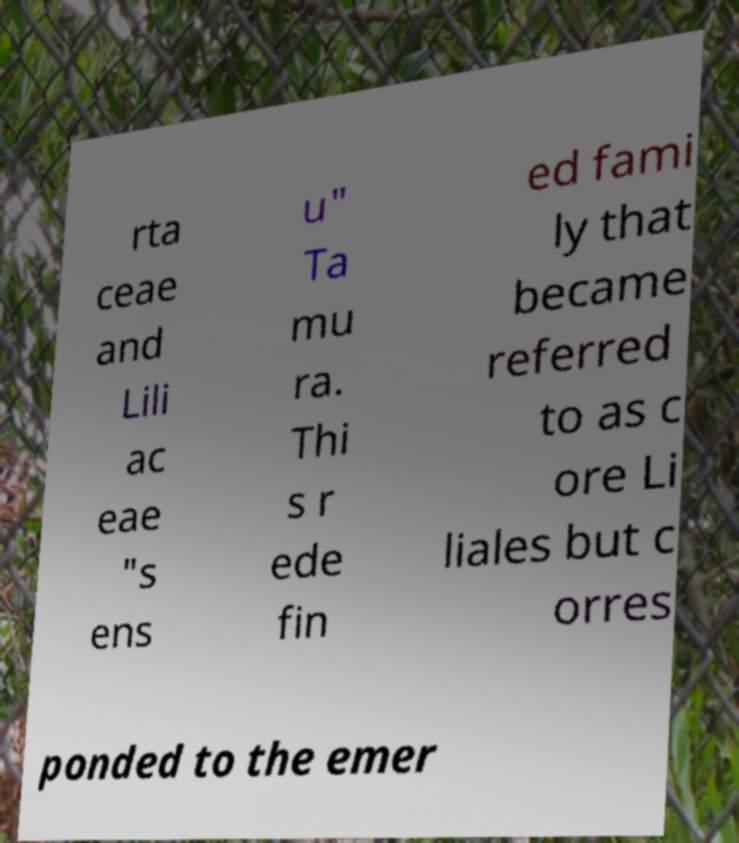I need the written content from this picture converted into text. Can you do that? rta ceae and Lili ac eae "s ens u" Ta mu ra. Thi s r ede fin ed fami ly that became referred to as c ore Li liales but c orres ponded to the emer 